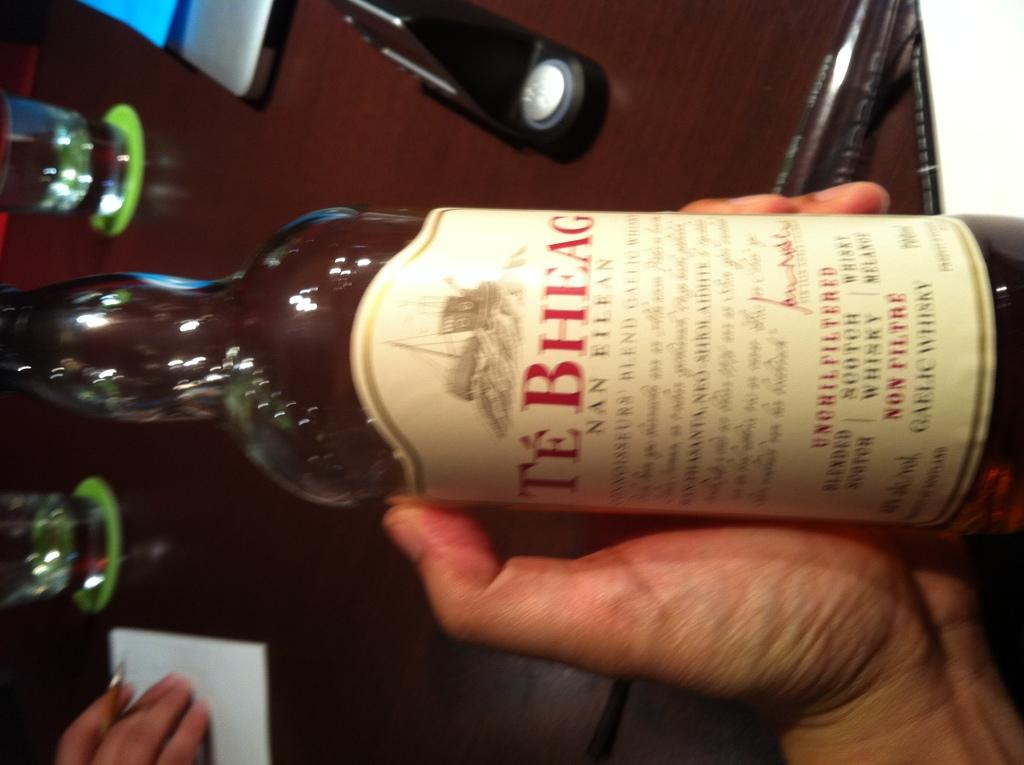Provide a one-sentence caption for the provided image. Te Bheag is the name displayed on the label of this whiskey bottle. 